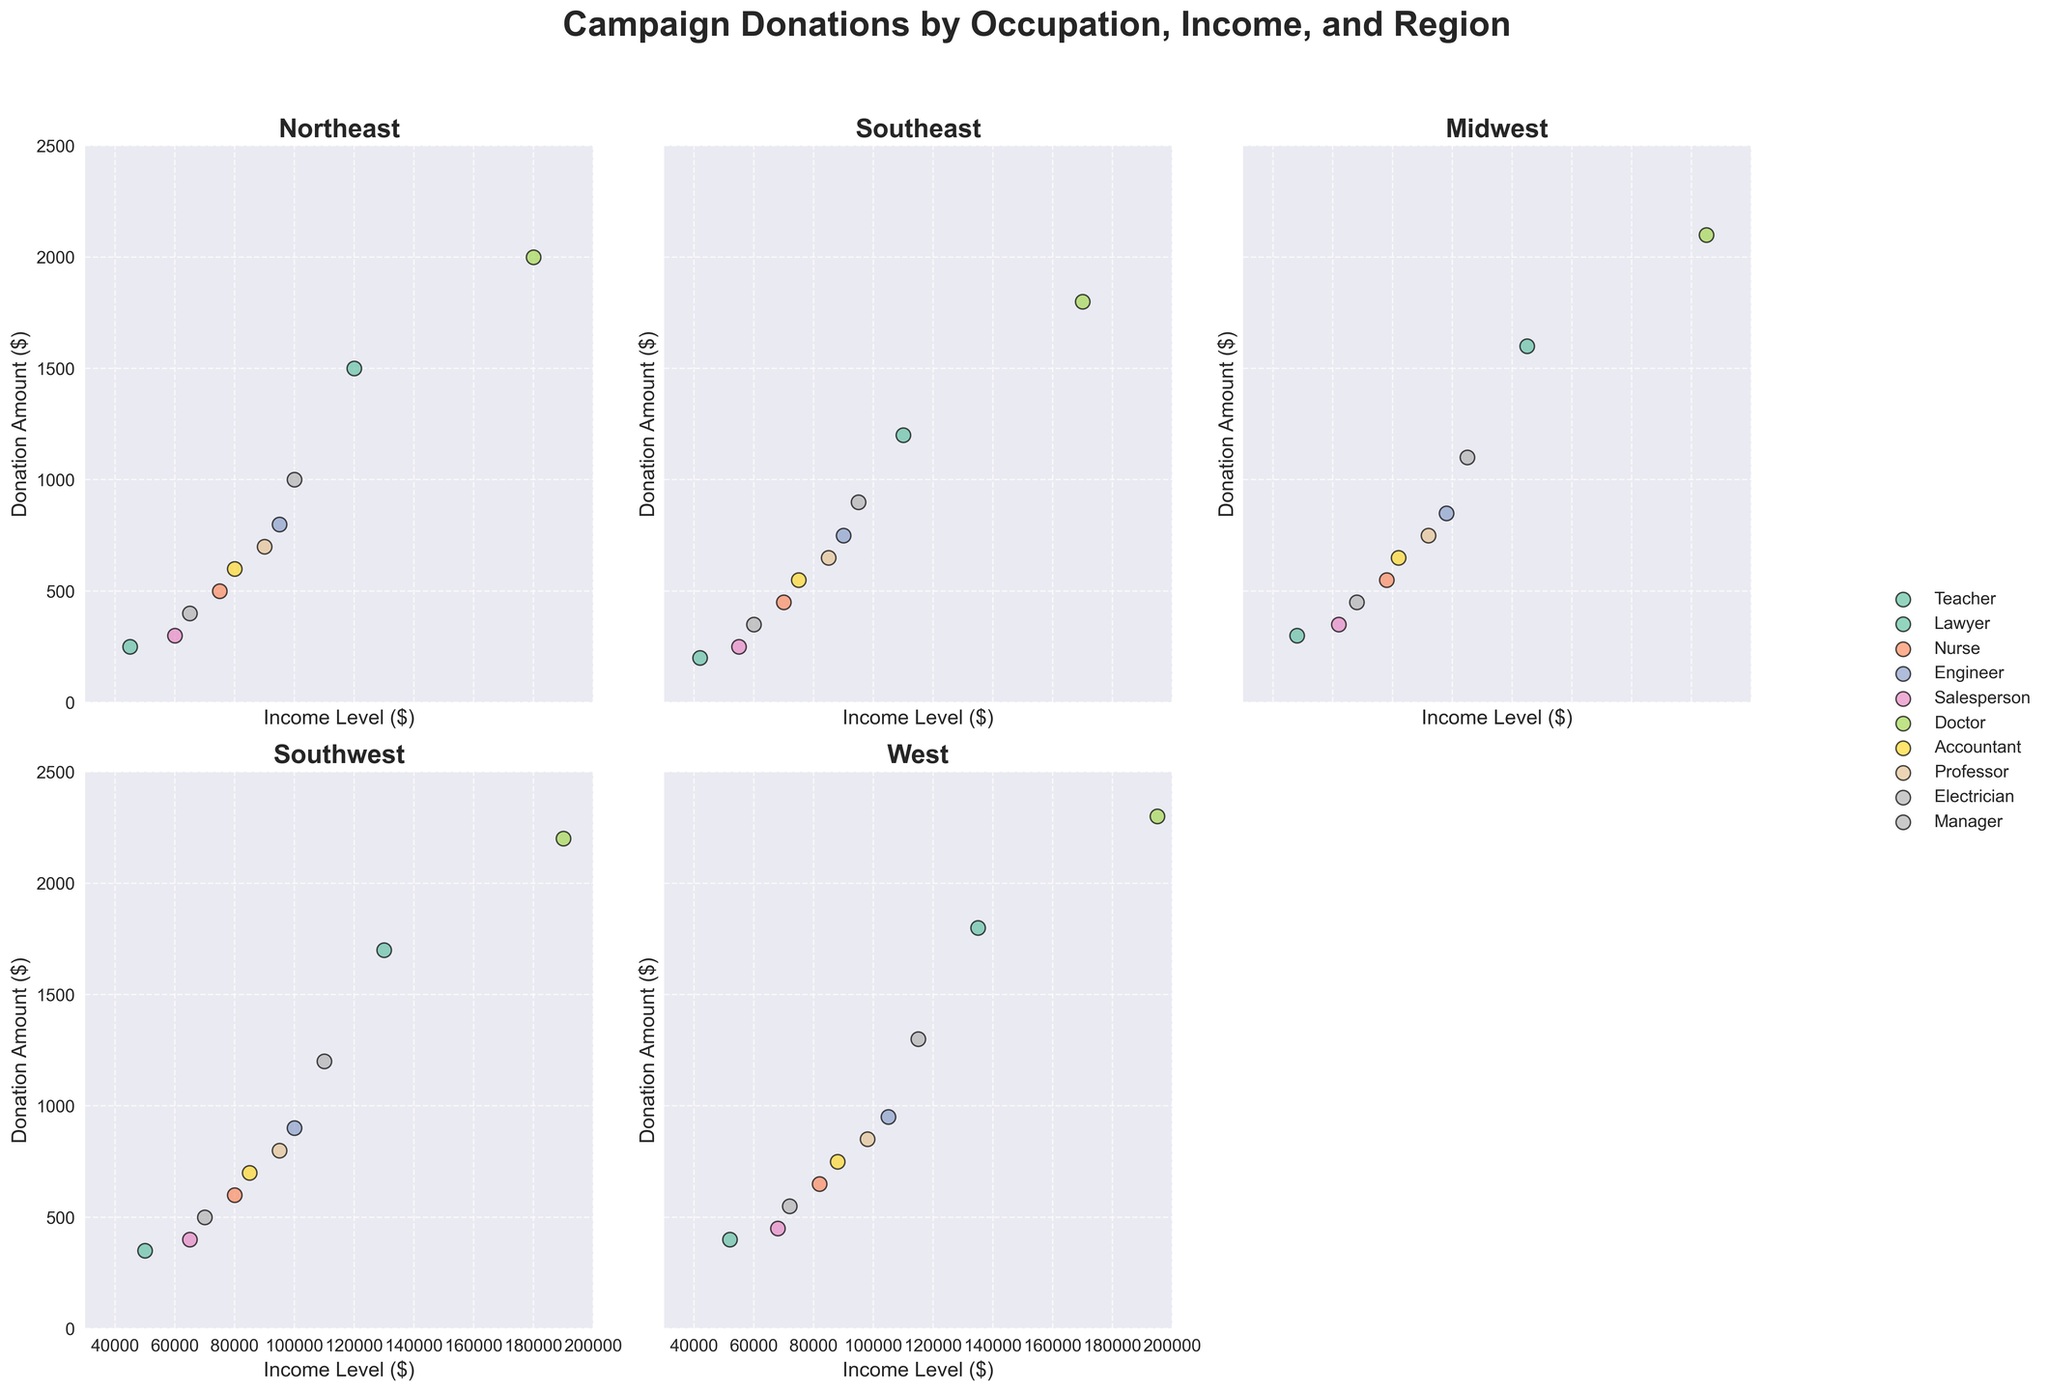Which region has the highest donation from Doctors? In the scatter plots, locate the points corresponding to Doctors in each region. The highest donation point for Doctors is $2300 in the West region.
Answer: West What is the average donation amount for Teachers in the Midwest? Identify the donation amounts for Teachers in the Midwest, which are $300, $350, and $400. The average is (300 + 350 + 400) / 3 = 350.
Answer: 350 Which region shows the highest variation in donation amounts among Engineers? Look for the scatter points corresponding to Engineers in each subplot. The West region shows donations ranging from $800 to $950, a range of $150.
Answer: West How do donation amounts for Electricians in the Northeast compare to those in the Southwest? Compare the scatter points for Electricians in the Northeast ($400) to those in the Southwest ($500).
Answer: Southwest is higher What is the total donation amount for Accountants across all regions? Sum the donation amounts for Accountants in all regions: $600 (Northeast) + $550 (Southeast) + $650 (Midwest) + $700 (Southwest) + $750 (West) = $3250.
Answer: 3250 What is the income level of Salespersons who donated the most in the West region? In the West subplot, identify the point for Salespersons with the highest donation amount ($450). The corresponding income level is $68000.
Answer: 68000 Do Lawyers in the Northeast or Southwest contribute higher average donations? Calculate average donation in Northeast: $1500. Average in Southwest: $1700. Compare these averages.
Answer: Southwest Which occupation consistently donates around $1000 across regions? Look for points near $1000 across all regions. Managers show donations of $1000 (Northeast), $900 (Southeast), $1100 (Midwest), $1200 (Southwest), $1300 (West).
Answer: Manager Which region displays the most diverse range of donation amounts for Nurses? Evaluate each region’s Nurse donation range. The West region shows donations from $600 to $650, a narrower range compared to others.
Answer: West Which occupation’s donation amount is clustered around $700 in most regions? Identify points around $700. Professors show donations of around $700 in many regions: $700 (Northeast), $650 (Southeast), $750 (Midwest), $800 (Southwest), $850 (West).
Answer: Professor 